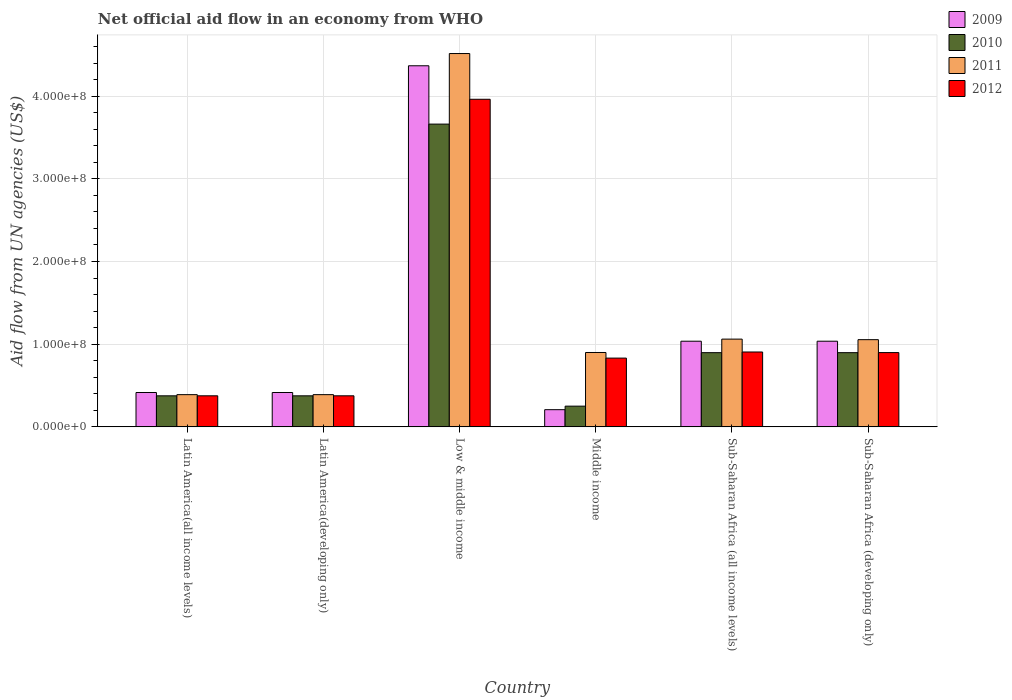Are the number of bars per tick equal to the number of legend labels?
Ensure brevity in your answer.  Yes. In how many cases, is the number of bars for a given country not equal to the number of legend labels?
Keep it short and to the point. 0. What is the net official aid flow in 2009 in Low & middle income?
Offer a terse response. 4.37e+08. Across all countries, what is the maximum net official aid flow in 2011?
Keep it short and to the point. 4.52e+08. Across all countries, what is the minimum net official aid flow in 2010?
Your response must be concise. 2.51e+07. In which country was the net official aid flow in 2012 maximum?
Your answer should be very brief. Low & middle income. What is the total net official aid flow in 2010 in the graph?
Your response must be concise. 6.46e+08. What is the difference between the net official aid flow in 2012 in Low & middle income and that in Sub-Saharan Africa (all income levels)?
Offer a very short reply. 3.06e+08. What is the difference between the net official aid flow in 2012 in Middle income and the net official aid flow in 2010 in Low & middle income?
Your answer should be very brief. -2.83e+08. What is the average net official aid flow in 2009 per country?
Your answer should be compact. 1.25e+08. What is the difference between the net official aid flow of/in 2012 and net official aid flow of/in 2009 in Latin America(all income levels)?
Offer a terse response. -3.99e+06. What is the ratio of the net official aid flow in 2011 in Latin America(developing only) to that in Sub-Saharan Africa (all income levels)?
Ensure brevity in your answer.  0.37. Is the net official aid flow in 2012 in Latin America(all income levels) less than that in Latin America(developing only)?
Keep it short and to the point. No. What is the difference between the highest and the second highest net official aid flow in 2011?
Ensure brevity in your answer.  3.46e+08. What is the difference between the highest and the lowest net official aid flow in 2009?
Your response must be concise. 4.16e+08. In how many countries, is the net official aid flow in 2009 greater than the average net official aid flow in 2009 taken over all countries?
Your response must be concise. 1. What does the 4th bar from the left in Low & middle income represents?
Give a very brief answer. 2012. What does the 1st bar from the right in Latin America(all income levels) represents?
Offer a terse response. 2012. How many bars are there?
Your answer should be very brief. 24. Are all the bars in the graph horizontal?
Ensure brevity in your answer.  No. How many countries are there in the graph?
Ensure brevity in your answer.  6. Are the values on the major ticks of Y-axis written in scientific E-notation?
Your answer should be compact. Yes. Does the graph contain any zero values?
Make the answer very short. No. How are the legend labels stacked?
Keep it short and to the point. Vertical. What is the title of the graph?
Your response must be concise. Net official aid flow in an economy from WHO. What is the label or title of the Y-axis?
Offer a terse response. Aid flow from UN agencies (US$). What is the Aid flow from UN agencies (US$) in 2009 in Latin America(all income levels)?
Make the answer very short. 4.16e+07. What is the Aid flow from UN agencies (US$) in 2010 in Latin America(all income levels)?
Make the answer very short. 3.76e+07. What is the Aid flow from UN agencies (US$) of 2011 in Latin America(all income levels)?
Your answer should be compact. 3.90e+07. What is the Aid flow from UN agencies (US$) of 2012 in Latin America(all income levels)?
Offer a very short reply. 3.76e+07. What is the Aid flow from UN agencies (US$) of 2009 in Latin America(developing only)?
Give a very brief answer. 4.16e+07. What is the Aid flow from UN agencies (US$) in 2010 in Latin America(developing only)?
Provide a short and direct response. 3.76e+07. What is the Aid flow from UN agencies (US$) of 2011 in Latin America(developing only)?
Provide a succinct answer. 3.90e+07. What is the Aid flow from UN agencies (US$) in 2012 in Latin America(developing only)?
Make the answer very short. 3.76e+07. What is the Aid flow from UN agencies (US$) of 2009 in Low & middle income?
Your response must be concise. 4.37e+08. What is the Aid flow from UN agencies (US$) of 2010 in Low & middle income?
Your answer should be very brief. 3.66e+08. What is the Aid flow from UN agencies (US$) in 2011 in Low & middle income?
Provide a short and direct response. 4.52e+08. What is the Aid flow from UN agencies (US$) in 2012 in Low & middle income?
Provide a succinct answer. 3.96e+08. What is the Aid flow from UN agencies (US$) of 2009 in Middle income?
Your response must be concise. 2.08e+07. What is the Aid flow from UN agencies (US$) in 2010 in Middle income?
Provide a short and direct response. 2.51e+07. What is the Aid flow from UN agencies (US$) in 2011 in Middle income?
Provide a short and direct response. 9.00e+07. What is the Aid flow from UN agencies (US$) in 2012 in Middle income?
Your response must be concise. 8.32e+07. What is the Aid flow from UN agencies (US$) of 2009 in Sub-Saharan Africa (all income levels)?
Make the answer very short. 1.04e+08. What is the Aid flow from UN agencies (US$) in 2010 in Sub-Saharan Africa (all income levels)?
Make the answer very short. 8.98e+07. What is the Aid flow from UN agencies (US$) in 2011 in Sub-Saharan Africa (all income levels)?
Make the answer very short. 1.06e+08. What is the Aid flow from UN agencies (US$) in 2012 in Sub-Saharan Africa (all income levels)?
Offer a terse response. 9.06e+07. What is the Aid flow from UN agencies (US$) in 2009 in Sub-Saharan Africa (developing only)?
Your answer should be very brief. 1.04e+08. What is the Aid flow from UN agencies (US$) in 2010 in Sub-Saharan Africa (developing only)?
Provide a succinct answer. 8.98e+07. What is the Aid flow from UN agencies (US$) of 2011 in Sub-Saharan Africa (developing only)?
Give a very brief answer. 1.05e+08. What is the Aid flow from UN agencies (US$) in 2012 in Sub-Saharan Africa (developing only)?
Make the answer very short. 8.98e+07. Across all countries, what is the maximum Aid flow from UN agencies (US$) of 2009?
Your answer should be compact. 4.37e+08. Across all countries, what is the maximum Aid flow from UN agencies (US$) in 2010?
Give a very brief answer. 3.66e+08. Across all countries, what is the maximum Aid flow from UN agencies (US$) of 2011?
Make the answer very short. 4.52e+08. Across all countries, what is the maximum Aid flow from UN agencies (US$) of 2012?
Keep it short and to the point. 3.96e+08. Across all countries, what is the minimum Aid flow from UN agencies (US$) in 2009?
Make the answer very short. 2.08e+07. Across all countries, what is the minimum Aid flow from UN agencies (US$) of 2010?
Provide a succinct answer. 2.51e+07. Across all countries, what is the minimum Aid flow from UN agencies (US$) of 2011?
Provide a short and direct response. 3.90e+07. Across all countries, what is the minimum Aid flow from UN agencies (US$) in 2012?
Provide a short and direct response. 3.76e+07. What is the total Aid flow from UN agencies (US$) in 2009 in the graph?
Offer a very short reply. 7.48e+08. What is the total Aid flow from UN agencies (US$) in 2010 in the graph?
Keep it short and to the point. 6.46e+08. What is the total Aid flow from UN agencies (US$) of 2011 in the graph?
Provide a succinct answer. 8.31e+08. What is the total Aid flow from UN agencies (US$) in 2012 in the graph?
Ensure brevity in your answer.  7.35e+08. What is the difference between the Aid flow from UN agencies (US$) of 2009 in Latin America(all income levels) and that in Latin America(developing only)?
Provide a succinct answer. 0. What is the difference between the Aid flow from UN agencies (US$) in 2010 in Latin America(all income levels) and that in Latin America(developing only)?
Provide a short and direct response. 0. What is the difference between the Aid flow from UN agencies (US$) in 2012 in Latin America(all income levels) and that in Latin America(developing only)?
Keep it short and to the point. 0. What is the difference between the Aid flow from UN agencies (US$) in 2009 in Latin America(all income levels) and that in Low & middle income?
Make the answer very short. -3.95e+08. What is the difference between the Aid flow from UN agencies (US$) in 2010 in Latin America(all income levels) and that in Low & middle income?
Your answer should be compact. -3.29e+08. What is the difference between the Aid flow from UN agencies (US$) of 2011 in Latin America(all income levels) and that in Low & middle income?
Your answer should be compact. -4.13e+08. What is the difference between the Aid flow from UN agencies (US$) in 2012 in Latin America(all income levels) and that in Low & middle income?
Ensure brevity in your answer.  -3.59e+08. What is the difference between the Aid flow from UN agencies (US$) in 2009 in Latin America(all income levels) and that in Middle income?
Your answer should be compact. 2.08e+07. What is the difference between the Aid flow from UN agencies (US$) in 2010 in Latin America(all income levels) and that in Middle income?
Ensure brevity in your answer.  1.25e+07. What is the difference between the Aid flow from UN agencies (US$) of 2011 in Latin America(all income levels) and that in Middle income?
Ensure brevity in your answer.  -5.10e+07. What is the difference between the Aid flow from UN agencies (US$) in 2012 in Latin America(all income levels) and that in Middle income?
Provide a succinct answer. -4.56e+07. What is the difference between the Aid flow from UN agencies (US$) in 2009 in Latin America(all income levels) and that in Sub-Saharan Africa (all income levels)?
Your answer should be very brief. -6.20e+07. What is the difference between the Aid flow from UN agencies (US$) in 2010 in Latin America(all income levels) and that in Sub-Saharan Africa (all income levels)?
Offer a very short reply. -5.22e+07. What is the difference between the Aid flow from UN agencies (US$) in 2011 in Latin America(all income levels) and that in Sub-Saharan Africa (all income levels)?
Your answer should be compact. -6.72e+07. What is the difference between the Aid flow from UN agencies (US$) of 2012 in Latin America(all income levels) and that in Sub-Saharan Africa (all income levels)?
Your answer should be very brief. -5.30e+07. What is the difference between the Aid flow from UN agencies (US$) in 2009 in Latin America(all income levels) and that in Sub-Saharan Africa (developing only)?
Your response must be concise. -6.20e+07. What is the difference between the Aid flow from UN agencies (US$) of 2010 in Latin America(all income levels) and that in Sub-Saharan Africa (developing only)?
Offer a very short reply. -5.22e+07. What is the difference between the Aid flow from UN agencies (US$) in 2011 in Latin America(all income levels) and that in Sub-Saharan Africa (developing only)?
Keep it short and to the point. -6.65e+07. What is the difference between the Aid flow from UN agencies (US$) of 2012 in Latin America(all income levels) and that in Sub-Saharan Africa (developing only)?
Make the answer very short. -5.23e+07. What is the difference between the Aid flow from UN agencies (US$) of 2009 in Latin America(developing only) and that in Low & middle income?
Provide a succinct answer. -3.95e+08. What is the difference between the Aid flow from UN agencies (US$) of 2010 in Latin America(developing only) and that in Low & middle income?
Your answer should be compact. -3.29e+08. What is the difference between the Aid flow from UN agencies (US$) in 2011 in Latin America(developing only) and that in Low & middle income?
Give a very brief answer. -4.13e+08. What is the difference between the Aid flow from UN agencies (US$) in 2012 in Latin America(developing only) and that in Low & middle income?
Keep it short and to the point. -3.59e+08. What is the difference between the Aid flow from UN agencies (US$) in 2009 in Latin America(developing only) and that in Middle income?
Provide a succinct answer. 2.08e+07. What is the difference between the Aid flow from UN agencies (US$) in 2010 in Latin America(developing only) and that in Middle income?
Provide a succinct answer. 1.25e+07. What is the difference between the Aid flow from UN agencies (US$) of 2011 in Latin America(developing only) and that in Middle income?
Provide a short and direct response. -5.10e+07. What is the difference between the Aid flow from UN agencies (US$) of 2012 in Latin America(developing only) and that in Middle income?
Give a very brief answer. -4.56e+07. What is the difference between the Aid flow from UN agencies (US$) in 2009 in Latin America(developing only) and that in Sub-Saharan Africa (all income levels)?
Your response must be concise. -6.20e+07. What is the difference between the Aid flow from UN agencies (US$) in 2010 in Latin America(developing only) and that in Sub-Saharan Africa (all income levels)?
Offer a terse response. -5.22e+07. What is the difference between the Aid flow from UN agencies (US$) of 2011 in Latin America(developing only) and that in Sub-Saharan Africa (all income levels)?
Your answer should be compact. -6.72e+07. What is the difference between the Aid flow from UN agencies (US$) in 2012 in Latin America(developing only) and that in Sub-Saharan Africa (all income levels)?
Offer a terse response. -5.30e+07. What is the difference between the Aid flow from UN agencies (US$) in 2009 in Latin America(developing only) and that in Sub-Saharan Africa (developing only)?
Offer a very short reply. -6.20e+07. What is the difference between the Aid flow from UN agencies (US$) of 2010 in Latin America(developing only) and that in Sub-Saharan Africa (developing only)?
Give a very brief answer. -5.22e+07. What is the difference between the Aid flow from UN agencies (US$) of 2011 in Latin America(developing only) and that in Sub-Saharan Africa (developing only)?
Your answer should be very brief. -6.65e+07. What is the difference between the Aid flow from UN agencies (US$) in 2012 in Latin America(developing only) and that in Sub-Saharan Africa (developing only)?
Offer a terse response. -5.23e+07. What is the difference between the Aid flow from UN agencies (US$) of 2009 in Low & middle income and that in Middle income?
Your response must be concise. 4.16e+08. What is the difference between the Aid flow from UN agencies (US$) in 2010 in Low & middle income and that in Middle income?
Your response must be concise. 3.41e+08. What is the difference between the Aid flow from UN agencies (US$) in 2011 in Low & middle income and that in Middle income?
Provide a succinct answer. 3.62e+08. What is the difference between the Aid flow from UN agencies (US$) in 2012 in Low & middle income and that in Middle income?
Make the answer very short. 3.13e+08. What is the difference between the Aid flow from UN agencies (US$) of 2009 in Low & middle income and that in Sub-Saharan Africa (all income levels)?
Make the answer very short. 3.33e+08. What is the difference between the Aid flow from UN agencies (US$) in 2010 in Low & middle income and that in Sub-Saharan Africa (all income levels)?
Keep it short and to the point. 2.76e+08. What is the difference between the Aid flow from UN agencies (US$) of 2011 in Low & middle income and that in Sub-Saharan Africa (all income levels)?
Your answer should be very brief. 3.45e+08. What is the difference between the Aid flow from UN agencies (US$) in 2012 in Low & middle income and that in Sub-Saharan Africa (all income levels)?
Your answer should be compact. 3.06e+08. What is the difference between the Aid flow from UN agencies (US$) in 2009 in Low & middle income and that in Sub-Saharan Africa (developing only)?
Ensure brevity in your answer.  3.33e+08. What is the difference between the Aid flow from UN agencies (US$) of 2010 in Low & middle income and that in Sub-Saharan Africa (developing only)?
Your response must be concise. 2.76e+08. What is the difference between the Aid flow from UN agencies (US$) in 2011 in Low & middle income and that in Sub-Saharan Africa (developing only)?
Your answer should be very brief. 3.46e+08. What is the difference between the Aid flow from UN agencies (US$) in 2012 in Low & middle income and that in Sub-Saharan Africa (developing only)?
Provide a short and direct response. 3.06e+08. What is the difference between the Aid flow from UN agencies (US$) in 2009 in Middle income and that in Sub-Saharan Africa (all income levels)?
Offer a very short reply. -8.28e+07. What is the difference between the Aid flow from UN agencies (US$) in 2010 in Middle income and that in Sub-Saharan Africa (all income levels)?
Offer a very short reply. -6.47e+07. What is the difference between the Aid flow from UN agencies (US$) in 2011 in Middle income and that in Sub-Saharan Africa (all income levels)?
Your answer should be compact. -1.62e+07. What is the difference between the Aid flow from UN agencies (US$) of 2012 in Middle income and that in Sub-Saharan Africa (all income levels)?
Make the answer very short. -7.39e+06. What is the difference between the Aid flow from UN agencies (US$) of 2009 in Middle income and that in Sub-Saharan Africa (developing only)?
Offer a very short reply. -8.28e+07. What is the difference between the Aid flow from UN agencies (US$) in 2010 in Middle income and that in Sub-Saharan Africa (developing only)?
Make the answer very short. -6.47e+07. What is the difference between the Aid flow from UN agencies (US$) of 2011 in Middle income and that in Sub-Saharan Africa (developing only)?
Ensure brevity in your answer.  -1.55e+07. What is the difference between the Aid flow from UN agencies (US$) in 2012 in Middle income and that in Sub-Saharan Africa (developing only)?
Ensure brevity in your answer.  -6.67e+06. What is the difference between the Aid flow from UN agencies (US$) in 2009 in Sub-Saharan Africa (all income levels) and that in Sub-Saharan Africa (developing only)?
Make the answer very short. 0. What is the difference between the Aid flow from UN agencies (US$) of 2011 in Sub-Saharan Africa (all income levels) and that in Sub-Saharan Africa (developing only)?
Provide a succinct answer. 6.70e+05. What is the difference between the Aid flow from UN agencies (US$) of 2012 in Sub-Saharan Africa (all income levels) and that in Sub-Saharan Africa (developing only)?
Your answer should be compact. 7.20e+05. What is the difference between the Aid flow from UN agencies (US$) in 2009 in Latin America(all income levels) and the Aid flow from UN agencies (US$) in 2010 in Latin America(developing only)?
Give a very brief answer. 4.01e+06. What is the difference between the Aid flow from UN agencies (US$) in 2009 in Latin America(all income levels) and the Aid flow from UN agencies (US$) in 2011 in Latin America(developing only)?
Keep it short and to the point. 2.59e+06. What is the difference between the Aid flow from UN agencies (US$) in 2009 in Latin America(all income levels) and the Aid flow from UN agencies (US$) in 2012 in Latin America(developing only)?
Provide a short and direct response. 3.99e+06. What is the difference between the Aid flow from UN agencies (US$) in 2010 in Latin America(all income levels) and the Aid flow from UN agencies (US$) in 2011 in Latin America(developing only)?
Ensure brevity in your answer.  -1.42e+06. What is the difference between the Aid flow from UN agencies (US$) of 2011 in Latin America(all income levels) and the Aid flow from UN agencies (US$) of 2012 in Latin America(developing only)?
Your answer should be compact. 1.40e+06. What is the difference between the Aid flow from UN agencies (US$) of 2009 in Latin America(all income levels) and the Aid flow from UN agencies (US$) of 2010 in Low & middle income?
Offer a terse response. -3.25e+08. What is the difference between the Aid flow from UN agencies (US$) of 2009 in Latin America(all income levels) and the Aid flow from UN agencies (US$) of 2011 in Low & middle income?
Provide a short and direct response. -4.10e+08. What is the difference between the Aid flow from UN agencies (US$) of 2009 in Latin America(all income levels) and the Aid flow from UN agencies (US$) of 2012 in Low & middle income?
Keep it short and to the point. -3.55e+08. What is the difference between the Aid flow from UN agencies (US$) in 2010 in Latin America(all income levels) and the Aid flow from UN agencies (US$) in 2011 in Low & middle income?
Your response must be concise. -4.14e+08. What is the difference between the Aid flow from UN agencies (US$) in 2010 in Latin America(all income levels) and the Aid flow from UN agencies (US$) in 2012 in Low & middle income?
Make the answer very short. -3.59e+08. What is the difference between the Aid flow from UN agencies (US$) in 2011 in Latin America(all income levels) and the Aid flow from UN agencies (US$) in 2012 in Low & middle income?
Offer a terse response. -3.57e+08. What is the difference between the Aid flow from UN agencies (US$) of 2009 in Latin America(all income levels) and the Aid flow from UN agencies (US$) of 2010 in Middle income?
Your response must be concise. 1.65e+07. What is the difference between the Aid flow from UN agencies (US$) of 2009 in Latin America(all income levels) and the Aid flow from UN agencies (US$) of 2011 in Middle income?
Offer a terse response. -4.84e+07. What is the difference between the Aid flow from UN agencies (US$) of 2009 in Latin America(all income levels) and the Aid flow from UN agencies (US$) of 2012 in Middle income?
Make the answer very short. -4.16e+07. What is the difference between the Aid flow from UN agencies (US$) of 2010 in Latin America(all income levels) and the Aid flow from UN agencies (US$) of 2011 in Middle income?
Your answer should be compact. -5.24e+07. What is the difference between the Aid flow from UN agencies (US$) in 2010 in Latin America(all income levels) and the Aid flow from UN agencies (US$) in 2012 in Middle income?
Make the answer very short. -4.56e+07. What is the difference between the Aid flow from UN agencies (US$) of 2011 in Latin America(all income levels) and the Aid flow from UN agencies (US$) of 2012 in Middle income?
Your answer should be very brief. -4.42e+07. What is the difference between the Aid flow from UN agencies (US$) in 2009 in Latin America(all income levels) and the Aid flow from UN agencies (US$) in 2010 in Sub-Saharan Africa (all income levels)?
Offer a terse response. -4.82e+07. What is the difference between the Aid flow from UN agencies (US$) in 2009 in Latin America(all income levels) and the Aid flow from UN agencies (US$) in 2011 in Sub-Saharan Africa (all income levels)?
Provide a succinct answer. -6.46e+07. What is the difference between the Aid flow from UN agencies (US$) in 2009 in Latin America(all income levels) and the Aid flow from UN agencies (US$) in 2012 in Sub-Saharan Africa (all income levels)?
Your response must be concise. -4.90e+07. What is the difference between the Aid flow from UN agencies (US$) of 2010 in Latin America(all income levels) and the Aid flow from UN agencies (US$) of 2011 in Sub-Saharan Africa (all income levels)?
Make the answer very short. -6.86e+07. What is the difference between the Aid flow from UN agencies (US$) of 2010 in Latin America(all income levels) and the Aid flow from UN agencies (US$) of 2012 in Sub-Saharan Africa (all income levels)?
Give a very brief answer. -5.30e+07. What is the difference between the Aid flow from UN agencies (US$) of 2011 in Latin America(all income levels) and the Aid flow from UN agencies (US$) of 2012 in Sub-Saharan Africa (all income levels)?
Provide a short and direct response. -5.16e+07. What is the difference between the Aid flow from UN agencies (US$) of 2009 in Latin America(all income levels) and the Aid flow from UN agencies (US$) of 2010 in Sub-Saharan Africa (developing only)?
Your response must be concise. -4.82e+07. What is the difference between the Aid flow from UN agencies (US$) of 2009 in Latin America(all income levels) and the Aid flow from UN agencies (US$) of 2011 in Sub-Saharan Africa (developing only)?
Provide a short and direct response. -6.39e+07. What is the difference between the Aid flow from UN agencies (US$) in 2009 in Latin America(all income levels) and the Aid flow from UN agencies (US$) in 2012 in Sub-Saharan Africa (developing only)?
Make the answer very short. -4.83e+07. What is the difference between the Aid flow from UN agencies (US$) in 2010 in Latin America(all income levels) and the Aid flow from UN agencies (US$) in 2011 in Sub-Saharan Africa (developing only)?
Your response must be concise. -6.79e+07. What is the difference between the Aid flow from UN agencies (US$) of 2010 in Latin America(all income levels) and the Aid flow from UN agencies (US$) of 2012 in Sub-Saharan Africa (developing only)?
Offer a very short reply. -5.23e+07. What is the difference between the Aid flow from UN agencies (US$) of 2011 in Latin America(all income levels) and the Aid flow from UN agencies (US$) of 2012 in Sub-Saharan Africa (developing only)?
Make the answer very short. -5.09e+07. What is the difference between the Aid flow from UN agencies (US$) in 2009 in Latin America(developing only) and the Aid flow from UN agencies (US$) in 2010 in Low & middle income?
Your response must be concise. -3.25e+08. What is the difference between the Aid flow from UN agencies (US$) of 2009 in Latin America(developing only) and the Aid flow from UN agencies (US$) of 2011 in Low & middle income?
Your response must be concise. -4.10e+08. What is the difference between the Aid flow from UN agencies (US$) of 2009 in Latin America(developing only) and the Aid flow from UN agencies (US$) of 2012 in Low & middle income?
Your answer should be very brief. -3.55e+08. What is the difference between the Aid flow from UN agencies (US$) in 2010 in Latin America(developing only) and the Aid flow from UN agencies (US$) in 2011 in Low & middle income?
Offer a terse response. -4.14e+08. What is the difference between the Aid flow from UN agencies (US$) in 2010 in Latin America(developing only) and the Aid flow from UN agencies (US$) in 2012 in Low & middle income?
Your answer should be compact. -3.59e+08. What is the difference between the Aid flow from UN agencies (US$) of 2011 in Latin America(developing only) and the Aid flow from UN agencies (US$) of 2012 in Low & middle income?
Keep it short and to the point. -3.57e+08. What is the difference between the Aid flow from UN agencies (US$) of 2009 in Latin America(developing only) and the Aid flow from UN agencies (US$) of 2010 in Middle income?
Your answer should be compact. 1.65e+07. What is the difference between the Aid flow from UN agencies (US$) of 2009 in Latin America(developing only) and the Aid flow from UN agencies (US$) of 2011 in Middle income?
Your answer should be compact. -4.84e+07. What is the difference between the Aid flow from UN agencies (US$) of 2009 in Latin America(developing only) and the Aid flow from UN agencies (US$) of 2012 in Middle income?
Offer a very short reply. -4.16e+07. What is the difference between the Aid flow from UN agencies (US$) in 2010 in Latin America(developing only) and the Aid flow from UN agencies (US$) in 2011 in Middle income?
Provide a succinct answer. -5.24e+07. What is the difference between the Aid flow from UN agencies (US$) in 2010 in Latin America(developing only) and the Aid flow from UN agencies (US$) in 2012 in Middle income?
Make the answer very short. -4.56e+07. What is the difference between the Aid flow from UN agencies (US$) of 2011 in Latin America(developing only) and the Aid flow from UN agencies (US$) of 2012 in Middle income?
Ensure brevity in your answer.  -4.42e+07. What is the difference between the Aid flow from UN agencies (US$) of 2009 in Latin America(developing only) and the Aid flow from UN agencies (US$) of 2010 in Sub-Saharan Africa (all income levels)?
Your answer should be compact. -4.82e+07. What is the difference between the Aid flow from UN agencies (US$) of 2009 in Latin America(developing only) and the Aid flow from UN agencies (US$) of 2011 in Sub-Saharan Africa (all income levels)?
Your answer should be compact. -6.46e+07. What is the difference between the Aid flow from UN agencies (US$) of 2009 in Latin America(developing only) and the Aid flow from UN agencies (US$) of 2012 in Sub-Saharan Africa (all income levels)?
Provide a short and direct response. -4.90e+07. What is the difference between the Aid flow from UN agencies (US$) of 2010 in Latin America(developing only) and the Aid flow from UN agencies (US$) of 2011 in Sub-Saharan Africa (all income levels)?
Provide a succinct answer. -6.86e+07. What is the difference between the Aid flow from UN agencies (US$) in 2010 in Latin America(developing only) and the Aid flow from UN agencies (US$) in 2012 in Sub-Saharan Africa (all income levels)?
Keep it short and to the point. -5.30e+07. What is the difference between the Aid flow from UN agencies (US$) in 2011 in Latin America(developing only) and the Aid flow from UN agencies (US$) in 2012 in Sub-Saharan Africa (all income levels)?
Keep it short and to the point. -5.16e+07. What is the difference between the Aid flow from UN agencies (US$) of 2009 in Latin America(developing only) and the Aid flow from UN agencies (US$) of 2010 in Sub-Saharan Africa (developing only)?
Give a very brief answer. -4.82e+07. What is the difference between the Aid flow from UN agencies (US$) in 2009 in Latin America(developing only) and the Aid flow from UN agencies (US$) in 2011 in Sub-Saharan Africa (developing only)?
Your response must be concise. -6.39e+07. What is the difference between the Aid flow from UN agencies (US$) of 2009 in Latin America(developing only) and the Aid flow from UN agencies (US$) of 2012 in Sub-Saharan Africa (developing only)?
Keep it short and to the point. -4.83e+07. What is the difference between the Aid flow from UN agencies (US$) in 2010 in Latin America(developing only) and the Aid flow from UN agencies (US$) in 2011 in Sub-Saharan Africa (developing only)?
Provide a succinct answer. -6.79e+07. What is the difference between the Aid flow from UN agencies (US$) of 2010 in Latin America(developing only) and the Aid flow from UN agencies (US$) of 2012 in Sub-Saharan Africa (developing only)?
Make the answer very short. -5.23e+07. What is the difference between the Aid flow from UN agencies (US$) of 2011 in Latin America(developing only) and the Aid flow from UN agencies (US$) of 2012 in Sub-Saharan Africa (developing only)?
Offer a terse response. -5.09e+07. What is the difference between the Aid flow from UN agencies (US$) in 2009 in Low & middle income and the Aid flow from UN agencies (US$) in 2010 in Middle income?
Offer a very short reply. 4.12e+08. What is the difference between the Aid flow from UN agencies (US$) in 2009 in Low & middle income and the Aid flow from UN agencies (US$) in 2011 in Middle income?
Your answer should be compact. 3.47e+08. What is the difference between the Aid flow from UN agencies (US$) in 2009 in Low & middle income and the Aid flow from UN agencies (US$) in 2012 in Middle income?
Provide a short and direct response. 3.54e+08. What is the difference between the Aid flow from UN agencies (US$) of 2010 in Low & middle income and the Aid flow from UN agencies (US$) of 2011 in Middle income?
Your answer should be very brief. 2.76e+08. What is the difference between the Aid flow from UN agencies (US$) in 2010 in Low & middle income and the Aid flow from UN agencies (US$) in 2012 in Middle income?
Your response must be concise. 2.83e+08. What is the difference between the Aid flow from UN agencies (US$) of 2011 in Low & middle income and the Aid flow from UN agencies (US$) of 2012 in Middle income?
Your answer should be compact. 3.68e+08. What is the difference between the Aid flow from UN agencies (US$) in 2009 in Low & middle income and the Aid flow from UN agencies (US$) in 2010 in Sub-Saharan Africa (all income levels)?
Your answer should be compact. 3.47e+08. What is the difference between the Aid flow from UN agencies (US$) in 2009 in Low & middle income and the Aid flow from UN agencies (US$) in 2011 in Sub-Saharan Africa (all income levels)?
Provide a short and direct response. 3.31e+08. What is the difference between the Aid flow from UN agencies (US$) of 2009 in Low & middle income and the Aid flow from UN agencies (US$) of 2012 in Sub-Saharan Africa (all income levels)?
Provide a succinct answer. 3.46e+08. What is the difference between the Aid flow from UN agencies (US$) in 2010 in Low & middle income and the Aid flow from UN agencies (US$) in 2011 in Sub-Saharan Africa (all income levels)?
Ensure brevity in your answer.  2.60e+08. What is the difference between the Aid flow from UN agencies (US$) of 2010 in Low & middle income and the Aid flow from UN agencies (US$) of 2012 in Sub-Saharan Africa (all income levels)?
Give a very brief answer. 2.76e+08. What is the difference between the Aid flow from UN agencies (US$) in 2011 in Low & middle income and the Aid flow from UN agencies (US$) in 2012 in Sub-Saharan Africa (all income levels)?
Provide a short and direct response. 3.61e+08. What is the difference between the Aid flow from UN agencies (US$) of 2009 in Low & middle income and the Aid flow from UN agencies (US$) of 2010 in Sub-Saharan Africa (developing only)?
Give a very brief answer. 3.47e+08. What is the difference between the Aid flow from UN agencies (US$) of 2009 in Low & middle income and the Aid flow from UN agencies (US$) of 2011 in Sub-Saharan Africa (developing only)?
Your answer should be compact. 3.31e+08. What is the difference between the Aid flow from UN agencies (US$) in 2009 in Low & middle income and the Aid flow from UN agencies (US$) in 2012 in Sub-Saharan Africa (developing only)?
Your response must be concise. 3.47e+08. What is the difference between the Aid flow from UN agencies (US$) of 2010 in Low & middle income and the Aid flow from UN agencies (US$) of 2011 in Sub-Saharan Africa (developing only)?
Keep it short and to the point. 2.61e+08. What is the difference between the Aid flow from UN agencies (US$) in 2010 in Low & middle income and the Aid flow from UN agencies (US$) in 2012 in Sub-Saharan Africa (developing only)?
Offer a terse response. 2.76e+08. What is the difference between the Aid flow from UN agencies (US$) in 2011 in Low & middle income and the Aid flow from UN agencies (US$) in 2012 in Sub-Saharan Africa (developing only)?
Provide a short and direct response. 3.62e+08. What is the difference between the Aid flow from UN agencies (US$) in 2009 in Middle income and the Aid flow from UN agencies (US$) in 2010 in Sub-Saharan Africa (all income levels)?
Your response must be concise. -6.90e+07. What is the difference between the Aid flow from UN agencies (US$) of 2009 in Middle income and the Aid flow from UN agencies (US$) of 2011 in Sub-Saharan Africa (all income levels)?
Ensure brevity in your answer.  -8.54e+07. What is the difference between the Aid flow from UN agencies (US$) in 2009 in Middle income and the Aid flow from UN agencies (US$) in 2012 in Sub-Saharan Africa (all income levels)?
Make the answer very short. -6.98e+07. What is the difference between the Aid flow from UN agencies (US$) in 2010 in Middle income and the Aid flow from UN agencies (US$) in 2011 in Sub-Saharan Africa (all income levels)?
Make the answer very short. -8.11e+07. What is the difference between the Aid flow from UN agencies (US$) of 2010 in Middle income and the Aid flow from UN agencies (US$) of 2012 in Sub-Saharan Africa (all income levels)?
Offer a terse response. -6.55e+07. What is the difference between the Aid flow from UN agencies (US$) of 2011 in Middle income and the Aid flow from UN agencies (US$) of 2012 in Sub-Saharan Africa (all income levels)?
Provide a short and direct response. -5.90e+05. What is the difference between the Aid flow from UN agencies (US$) of 2009 in Middle income and the Aid flow from UN agencies (US$) of 2010 in Sub-Saharan Africa (developing only)?
Provide a short and direct response. -6.90e+07. What is the difference between the Aid flow from UN agencies (US$) in 2009 in Middle income and the Aid flow from UN agencies (US$) in 2011 in Sub-Saharan Africa (developing only)?
Give a very brief answer. -8.47e+07. What is the difference between the Aid flow from UN agencies (US$) of 2009 in Middle income and the Aid flow from UN agencies (US$) of 2012 in Sub-Saharan Africa (developing only)?
Keep it short and to the point. -6.90e+07. What is the difference between the Aid flow from UN agencies (US$) of 2010 in Middle income and the Aid flow from UN agencies (US$) of 2011 in Sub-Saharan Africa (developing only)?
Your response must be concise. -8.04e+07. What is the difference between the Aid flow from UN agencies (US$) of 2010 in Middle income and the Aid flow from UN agencies (US$) of 2012 in Sub-Saharan Africa (developing only)?
Make the answer very short. -6.48e+07. What is the difference between the Aid flow from UN agencies (US$) of 2009 in Sub-Saharan Africa (all income levels) and the Aid flow from UN agencies (US$) of 2010 in Sub-Saharan Africa (developing only)?
Your answer should be compact. 1.39e+07. What is the difference between the Aid flow from UN agencies (US$) of 2009 in Sub-Saharan Africa (all income levels) and the Aid flow from UN agencies (US$) of 2011 in Sub-Saharan Africa (developing only)?
Ensure brevity in your answer.  -1.86e+06. What is the difference between the Aid flow from UN agencies (US$) in 2009 in Sub-Saharan Africa (all income levels) and the Aid flow from UN agencies (US$) in 2012 in Sub-Saharan Africa (developing only)?
Your response must be concise. 1.38e+07. What is the difference between the Aid flow from UN agencies (US$) in 2010 in Sub-Saharan Africa (all income levels) and the Aid flow from UN agencies (US$) in 2011 in Sub-Saharan Africa (developing only)?
Offer a very short reply. -1.57e+07. What is the difference between the Aid flow from UN agencies (US$) in 2011 in Sub-Saharan Africa (all income levels) and the Aid flow from UN agencies (US$) in 2012 in Sub-Saharan Africa (developing only)?
Offer a very short reply. 1.63e+07. What is the average Aid flow from UN agencies (US$) in 2009 per country?
Your answer should be compact. 1.25e+08. What is the average Aid flow from UN agencies (US$) of 2010 per country?
Make the answer very short. 1.08e+08. What is the average Aid flow from UN agencies (US$) of 2011 per country?
Make the answer very short. 1.39e+08. What is the average Aid flow from UN agencies (US$) of 2012 per country?
Offer a very short reply. 1.23e+08. What is the difference between the Aid flow from UN agencies (US$) in 2009 and Aid flow from UN agencies (US$) in 2010 in Latin America(all income levels)?
Provide a succinct answer. 4.01e+06. What is the difference between the Aid flow from UN agencies (US$) in 2009 and Aid flow from UN agencies (US$) in 2011 in Latin America(all income levels)?
Your response must be concise. 2.59e+06. What is the difference between the Aid flow from UN agencies (US$) of 2009 and Aid flow from UN agencies (US$) of 2012 in Latin America(all income levels)?
Your answer should be very brief. 3.99e+06. What is the difference between the Aid flow from UN agencies (US$) of 2010 and Aid flow from UN agencies (US$) of 2011 in Latin America(all income levels)?
Make the answer very short. -1.42e+06. What is the difference between the Aid flow from UN agencies (US$) of 2011 and Aid flow from UN agencies (US$) of 2012 in Latin America(all income levels)?
Your response must be concise. 1.40e+06. What is the difference between the Aid flow from UN agencies (US$) in 2009 and Aid flow from UN agencies (US$) in 2010 in Latin America(developing only)?
Keep it short and to the point. 4.01e+06. What is the difference between the Aid flow from UN agencies (US$) in 2009 and Aid flow from UN agencies (US$) in 2011 in Latin America(developing only)?
Provide a short and direct response. 2.59e+06. What is the difference between the Aid flow from UN agencies (US$) of 2009 and Aid flow from UN agencies (US$) of 2012 in Latin America(developing only)?
Provide a short and direct response. 3.99e+06. What is the difference between the Aid flow from UN agencies (US$) in 2010 and Aid flow from UN agencies (US$) in 2011 in Latin America(developing only)?
Provide a short and direct response. -1.42e+06. What is the difference between the Aid flow from UN agencies (US$) in 2011 and Aid flow from UN agencies (US$) in 2012 in Latin America(developing only)?
Your answer should be very brief. 1.40e+06. What is the difference between the Aid flow from UN agencies (US$) in 2009 and Aid flow from UN agencies (US$) in 2010 in Low & middle income?
Make the answer very short. 7.06e+07. What is the difference between the Aid flow from UN agencies (US$) in 2009 and Aid flow from UN agencies (US$) in 2011 in Low & middle income?
Make the answer very short. -1.48e+07. What is the difference between the Aid flow from UN agencies (US$) of 2009 and Aid flow from UN agencies (US$) of 2012 in Low & middle income?
Your response must be concise. 4.05e+07. What is the difference between the Aid flow from UN agencies (US$) of 2010 and Aid flow from UN agencies (US$) of 2011 in Low & middle income?
Your answer should be compact. -8.54e+07. What is the difference between the Aid flow from UN agencies (US$) of 2010 and Aid flow from UN agencies (US$) of 2012 in Low & middle income?
Your answer should be compact. -3.00e+07. What is the difference between the Aid flow from UN agencies (US$) of 2011 and Aid flow from UN agencies (US$) of 2012 in Low & middle income?
Provide a succinct answer. 5.53e+07. What is the difference between the Aid flow from UN agencies (US$) in 2009 and Aid flow from UN agencies (US$) in 2010 in Middle income?
Make the answer very short. -4.27e+06. What is the difference between the Aid flow from UN agencies (US$) in 2009 and Aid flow from UN agencies (US$) in 2011 in Middle income?
Offer a very short reply. -6.92e+07. What is the difference between the Aid flow from UN agencies (US$) of 2009 and Aid flow from UN agencies (US$) of 2012 in Middle income?
Keep it short and to the point. -6.24e+07. What is the difference between the Aid flow from UN agencies (US$) of 2010 and Aid flow from UN agencies (US$) of 2011 in Middle income?
Provide a short and direct response. -6.49e+07. What is the difference between the Aid flow from UN agencies (US$) in 2010 and Aid flow from UN agencies (US$) in 2012 in Middle income?
Your answer should be compact. -5.81e+07. What is the difference between the Aid flow from UN agencies (US$) in 2011 and Aid flow from UN agencies (US$) in 2012 in Middle income?
Provide a short and direct response. 6.80e+06. What is the difference between the Aid flow from UN agencies (US$) in 2009 and Aid flow from UN agencies (US$) in 2010 in Sub-Saharan Africa (all income levels)?
Your answer should be compact. 1.39e+07. What is the difference between the Aid flow from UN agencies (US$) of 2009 and Aid flow from UN agencies (US$) of 2011 in Sub-Saharan Africa (all income levels)?
Your answer should be compact. -2.53e+06. What is the difference between the Aid flow from UN agencies (US$) in 2009 and Aid flow from UN agencies (US$) in 2012 in Sub-Saharan Africa (all income levels)?
Offer a terse response. 1.30e+07. What is the difference between the Aid flow from UN agencies (US$) of 2010 and Aid flow from UN agencies (US$) of 2011 in Sub-Saharan Africa (all income levels)?
Your answer should be very brief. -1.64e+07. What is the difference between the Aid flow from UN agencies (US$) of 2010 and Aid flow from UN agencies (US$) of 2012 in Sub-Saharan Africa (all income levels)?
Your answer should be very brief. -8.10e+05. What is the difference between the Aid flow from UN agencies (US$) in 2011 and Aid flow from UN agencies (US$) in 2012 in Sub-Saharan Africa (all income levels)?
Keep it short and to the point. 1.56e+07. What is the difference between the Aid flow from UN agencies (US$) in 2009 and Aid flow from UN agencies (US$) in 2010 in Sub-Saharan Africa (developing only)?
Offer a terse response. 1.39e+07. What is the difference between the Aid flow from UN agencies (US$) in 2009 and Aid flow from UN agencies (US$) in 2011 in Sub-Saharan Africa (developing only)?
Provide a succinct answer. -1.86e+06. What is the difference between the Aid flow from UN agencies (US$) in 2009 and Aid flow from UN agencies (US$) in 2012 in Sub-Saharan Africa (developing only)?
Keep it short and to the point. 1.38e+07. What is the difference between the Aid flow from UN agencies (US$) in 2010 and Aid flow from UN agencies (US$) in 2011 in Sub-Saharan Africa (developing only)?
Your answer should be very brief. -1.57e+07. What is the difference between the Aid flow from UN agencies (US$) in 2011 and Aid flow from UN agencies (US$) in 2012 in Sub-Saharan Africa (developing only)?
Your response must be concise. 1.56e+07. What is the ratio of the Aid flow from UN agencies (US$) of 2010 in Latin America(all income levels) to that in Latin America(developing only)?
Ensure brevity in your answer.  1. What is the ratio of the Aid flow from UN agencies (US$) of 2011 in Latin America(all income levels) to that in Latin America(developing only)?
Provide a succinct answer. 1. What is the ratio of the Aid flow from UN agencies (US$) of 2012 in Latin America(all income levels) to that in Latin America(developing only)?
Provide a succinct answer. 1. What is the ratio of the Aid flow from UN agencies (US$) in 2009 in Latin America(all income levels) to that in Low & middle income?
Your answer should be very brief. 0.1. What is the ratio of the Aid flow from UN agencies (US$) in 2010 in Latin America(all income levels) to that in Low & middle income?
Make the answer very short. 0.1. What is the ratio of the Aid flow from UN agencies (US$) of 2011 in Latin America(all income levels) to that in Low & middle income?
Give a very brief answer. 0.09. What is the ratio of the Aid flow from UN agencies (US$) of 2012 in Latin America(all income levels) to that in Low & middle income?
Ensure brevity in your answer.  0.09. What is the ratio of the Aid flow from UN agencies (US$) in 2009 in Latin America(all income levels) to that in Middle income?
Your answer should be compact. 2. What is the ratio of the Aid flow from UN agencies (US$) in 2010 in Latin America(all income levels) to that in Middle income?
Give a very brief answer. 1.5. What is the ratio of the Aid flow from UN agencies (US$) of 2011 in Latin America(all income levels) to that in Middle income?
Keep it short and to the point. 0.43. What is the ratio of the Aid flow from UN agencies (US$) of 2012 in Latin America(all income levels) to that in Middle income?
Make the answer very short. 0.45. What is the ratio of the Aid flow from UN agencies (US$) of 2009 in Latin America(all income levels) to that in Sub-Saharan Africa (all income levels)?
Give a very brief answer. 0.4. What is the ratio of the Aid flow from UN agencies (US$) of 2010 in Latin America(all income levels) to that in Sub-Saharan Africa (all income levels)?
Offer a very short reply. 0.42. What is the ratio of the Aid flow from UN agencies (US$) of 2011 in Latin America(all income levels) to that in Sub-Saharan Africa (all income levels)?
Provide a short and direct response. 0.37. What is the ratio of the Aid flow from UN agencies (US$) of 2012 in Latin America(all income levels) to that in Sub-Saharan Africa (all income levels)?
Give a very brief answer. 0.41. What is the ratio of the Aid flow from UN agencies (US$) of 2009 in Latin America(all income levels) to that in Sub-Saharan Africa (developing only)?
Your answer should be compact. 0.4. What is the ratio of the Aid flow from UN agencies (US$) in 2010 in Latin America(all income levels) to that in Sub-Saharan Africa (developing only)?
Make the answer very short. 0.42. What is the ratio of the Aid flow from UN agencies (US$) in 2011 in Latin America(all income levels) to that in Sub-Saharan Africa (developing only)?
Keep it short and to the point. 0.37. What is the ratio of the Aid flow from UN agencies (US$) of 2012 in Latin America(all income levels) to that in Sub-Saharan Africa (developing only)?
Give a very brief answer. 0.42. What is the ratio of the Aid flow from UN agencies (US$) in 2009 in Latin America(developing only) to that in Low & middle income?
Offer a terse response. 0.1. What is the ratio of the Aid flow from UN agencies (US$) in 2010 in Latin America(developing only) to that in Low & middle income?
Keep it short and to the point. 0.1. What is the ratio of the Aid flow from UN agencies (US$) in 2011 in Latin America(developing only) to that in Low & middle income?
Make the answer very short. 0.09. What is the ratio of the Aid flow from UN agencies (US$) of 2012 in Latin America(developing only) to that in Low & middle income?
Provide a succinct answer. 0.09. What is the ratio of the Aid flow from UN agencies (US$) of 2009 in Latin America(developing only) to that in Middle income?
Provide a succinct answer. 2. What is the ratio of the Aid flow from UN agencies (US$) in 2010 in Latin America(developing only) to that in Middle income?
Provide a succinct answer. 1.5. What is the ratio of the Aid flow from UN agencies (US$) of 2011 in Latin America(developing only) to that in Middle income?
Make the answer very short. 0.43. What is the ratio of the Aid flow from UN agencies (US$) of 2012 in Latin America(developing only) to that in Middle income?
Offer a terse response. 0.45. What is the ratio of the Aid flow from UN agencies (US$) in 2009 in Latin America(developing only) to that in Sub-Saharan Africa (all income levels)?
Provide a succinct answer. 0.4. What is the ratio of the Aid flow from UN agencies (US$) in 2010 in Latin America(developing only) to that in Sub-Saharan Africa (all income levels)?
Keep it short and to the point. 0.42. What is the ratio of the Aid flow from UN agencies (US$) in 2011 in Latin America(developing only) to that in Sub-Saharan Africa (all income levels)?
Make the answer very short. 0.37. What is the ratio of the Aid flow from UN agencies (US$) of 2012 in Latin America(developing only) to that in Sub-Saharan Africa (all income levels)?
Your response must be concise. 0.41. What is the ratio of the Aid flow from UN agencies (US$) in 2009 in Latin America(developing only) to that in Sub-Saharan Africa (developing only)?
Offer a terse response. 0.4. What is the ratio of the Aid flow from UN agencies (US$) of 2010 in Latin America(developing only) to that in Sub-Saharan Africa (developing only)?
Offer a terse response. 0.42. What is the ratio of the Aid flow from UN agencies (US$) of 2011 in Latin America(developing only) to that in Sub-Saharan Africa (developing only)?
Provide a succinct answer. 0.37. What is the ratio of the Aid flow from UN agencies (US$) of 2012 in Latin America(developing only) to that in Sub-Saharan Africa (developing only)?
Provide a short and direct response. 0.42. What is the ratio of the Aid flow from UN agencies (US$) of 2009 in Low & middle income to that in Middle income?
Provide a short and direct response. 21. What is the ratio of the Aid flow from UN agencies (US$) of 2010 in Low & middle income to that in Middle income?
Your response must be concise. 14.61. What is the ratio of the Aid flow from UN agencies (US$) in 2011 in Low & middle income to that in Middle income?
Provide a short and direct response. 5.02. What is the ratio of the Aid flow from UN agencies (US$) of 2012 in Low & middle income to that in Middle income?
Offer a very short reply. 4.76. What is the ratio of the Aid flow from UN agencies (US$) of 2009 in Low & middle income to that in Sub-Saharan Africa (all income levels)?
Your answer should be very brief. 4.22. What is the ratio of the Aid flow from UN agencies (US$) of 2010 in Low & middle income to that in Sub-Saharan Africa (all income levels)?
Make the answer very short. 4.08. What is the ratio of the Aid flow from UN agencies (US$) in 2011 in Low & middle income to that in Sub-Saharan Africa (all income levels)?
Your response must be concise. 4.25. What is the ratio of the Aid flow from UN agencies (US$) in 2012 in Low & middle income to that in Sub-Saharan Africa (all income levels)?
Give a very brief answer. 4.38. What is the ratio of the Aid flow from UN agencies (US$) in 2009 in Low & middle income to that in Sub-Saharan Africa (developing only)?
Your response must be concise. 4.22. What is the ratio of the Aid flow from UN agencies (US$) of 2010 in Low & middle income to that in Sub-Saharan Africa (developing only)?
Your answer should be very brief. 4.08. What is the ratio of the Aid flow from UN agencies (US$) in 2011 in Low & middle income to that in Sub-Saharan Africa (developing only)?
Provide a short and direct response. 4.28. What is the ratio of the Aid flow from UN agencies (US$) in 2012 in Low & middle income to that in Sub-Saharan Africa (developing only)?
Offer a terse response. 4.41. What is the ratio of the Aid flow from UN agencies (US$) of 2009 in Middle income to that in Sub-Saharan Africa (all income levels)?
Make the answer very short. 0.2. What is the ratio of the Aid flow from UN agencies (US$) of 2010 in Middle income to that in Sub-Saharan Africa (all income levels)?
Ensure brevity in your answer.  0.28. What is the ratio of the Aid flow from UN agencies (US$) in 2011 in Middle income to that in Sub-Saharan Africa (all income levels)?
Provide a succinct answer. 0.85. What is the ratio of the Aid flow from UN agencies (US$) of 2012 in Middle income to that in Sub-Saharan Africa (all income levels)?
Offer a very short reply. 0.92. What is the ratio of the Aid flow from UN agencies (US$) in 2009 in Middle income to that in Sub-Saharan Africa (developing only)?
Offer a terse response. 0.2. What is the ratio of the Aid flow from UN agencies (US$) of 2010 in Middle income to that in Sub-Saharan Africa (developing only)?
Provide a succinct answer. 0.28. What is the ratio of the Aid flow from UN agencies (US$) in 2011 in Middle income to that in Sub-Saharan Africa (developing only)?
Ensure brevity in your answer.  0.85. What is the ratio of the Aid flow from UN agencies (US$) in 2012 in Middle income to that in Sub-Saharan Africa (developing only)?
Your answer should be compact. 0.93. What is the ratio of the Aid flow from UN agencies (US$) in 2009 in Sub-Saharan Africa (all income levels) to that in Sub-Saharan Africa (developing only)?
Ensure brevity in your answer.  1. What is the ratio of the Aid flow from UN agencies (US$) of 2011 in Sub-Saharan Africa (all income levels) to that in Sub-Saharan Africa (developing only)?
Make the answer very short. 1.01. What is the ratio of the Aid flow from UN agencies (US$) of 2012 in Sub-Saharan Africa (all income levels) to that in Sub-Saharan Africa (developing only)?
Your answer should be compact. 1.01. What is the difference between the highest and the second highest Aid flow from UN agencies (US$) of 2009?
Offer a very short reply. 3.33e+08. What is the difference between the highest and the second highest Aid flow from UN agencies (US$) in 2010?
Provide a succinct answer. 2.76e+08. What is the difference between the highest and the second highest Aid flow from UN agencies (US$) in 2011?
Your answer should be compact. 3.45e+08. What is the difference between the highest and the second highest Aid flow from UN agencies (US$) of 2012?
Your answer should be very brief. 3.06e+08. What is the difference between the highest and the lowest Aid flow from UN agencies (US$) of 2009?
Your answer should be very brief. 4.16e+08. What is the difference between the highest and the lowest Aid flow from UN agencies (US$) of 2010?
Keep it short and to the point. 3.41e+08. What is the difference between the highest and the lowest Aid flow from UN agencies (US$) in 2011?
Offer a very short reply. 4.13e+08. What is the difference between the highest and the lowest Aid flow from UN agencies (US$) of 2012?
Provide a succinct answer. 3.59e+08. 